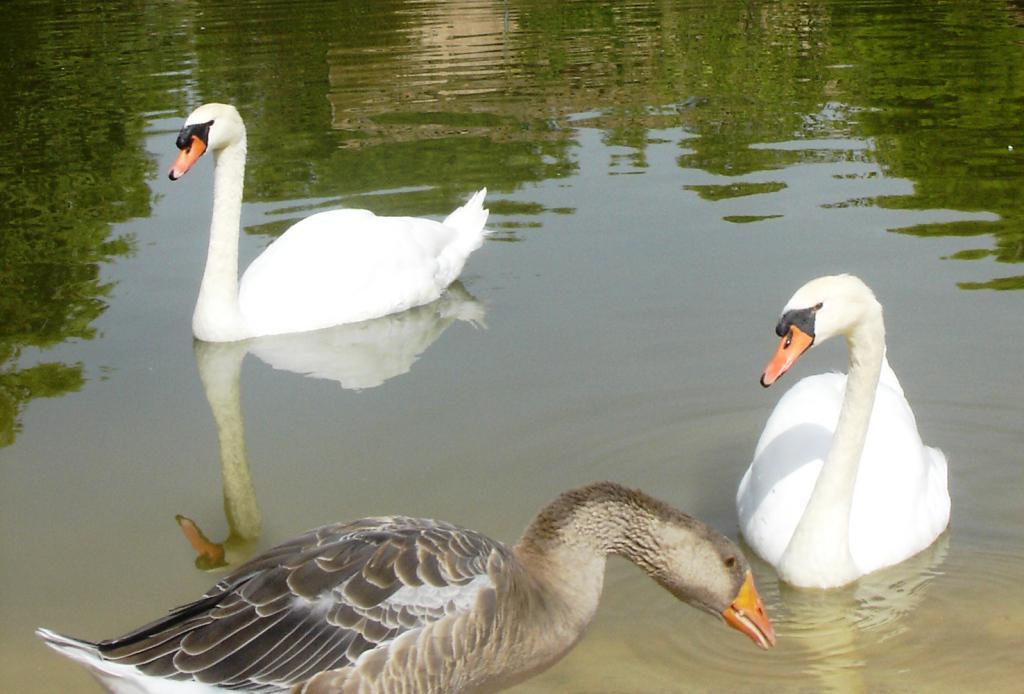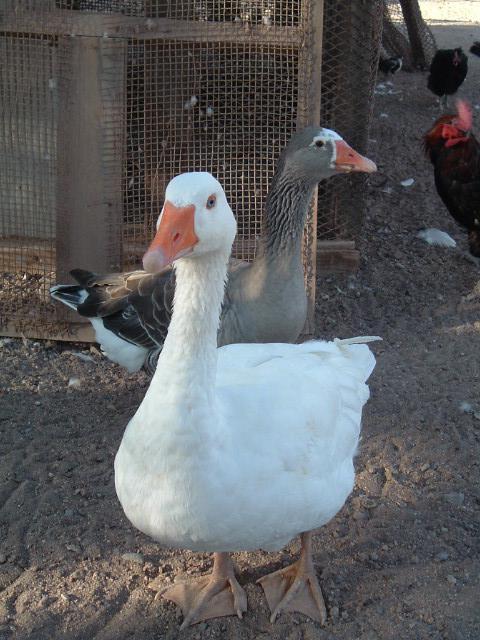The first image is the image on the left, the second image is the image on the right. Considering the images on both sides, is "Every single image features more than one bird." valid? Answer yes or no. Yes. 